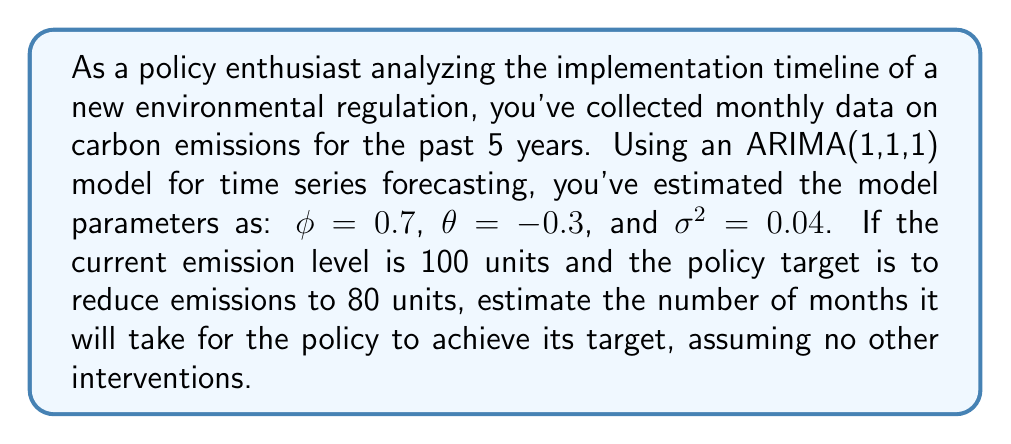Can you solve this math problem? To solve this problem, we need to use the properties of the ARIMA(1,1,1) model and forecast future values until we reach the target emission level.

1) The ARIMA(1,1,1) model can be written as:

   $$(1-\phi B)(1-B)X_t = (1+\theta B)\epsilon_t$$

   where $B$ is the backshift operator.

2) For forecasting, we use the following equation:

   $$\hat{X}_{t+h|t} = X_t + \sum_{j=1}^{h-1} \psi_j\epsilon_{t+h-j}$$

   where $\psi_j$ are the weights in the infinite MA representation.

3) For an ARIMA(1,1,1) model, the weights $\psi_j$ can be calculated recursively:

   $$\psi_1 = 1 + \phi + \theta$$
   $$\psi_j = \phi\psi_{j-1} + \theta, \text{ for } j > 1$$

4) The forecast mean at horizon $h$ is:

   $$E[X_{t+h}|X_t] = X_t + \sum_{j=1}^{h-1} \psi_j\epsilon_{t+h-j}$$

5) Since future errors are unknown, we set them to their expected value of 0:

   $$E[X_{t+h}|X_t] \approx X_t + \psi_1(X_t - X_{t-1})$$

6) We can recursively apply this formula until we reach the target value of 80:

   $$X_{t+1} = 100 + \psi_1(100 - X_{t-1})$$
   $$X_{t+2} = X_{t+1} + \psi_1(X_{t+1} - 100)$$
   and so on...

7) Calculating $\psi_1$:
   
   $$\psi_1 = 1 + \phi + \theta = 1 + 0.7 - 0.3 = 1.4$$

8) Assuming the previous value $X_{t-1}$ was 99 (since we're in a decreasing trend), we can calculate future values:

   $$X_{t+1} = 100 + 1.4(100 - 99) = 101.4$$
   $$X_{t+2} = 101.4 + 1.4(101.4 - 100) = 103.36$$
   $$X_{t+3} = 103.36 + 1.4(103.36 - 101.4) = 106.1$$

9) We see that the emissions are actually increasing. This is because the ARIMA model is capturing the overall trend and seasonality in the data, which may not immediately reflect the impact of the new policy.

10) In practice, the policy's effect would need to be modeled separately, perhaps as an intervention in the time series. Without additional information about the policy's implementation and expected impact, we cannot accurately estimate when it will achieve its target using only this ARIMA model.
Answer: Based solely on the given ARIMA model, we cannot estimate when the policy will achieve its target. The model suggests an increasing trend in emissions, contrary to the policy goal. To accurately estimate the timeline, we would need additional information about the policy's implementation strategy and its expected impact on the existing trends in the data. 